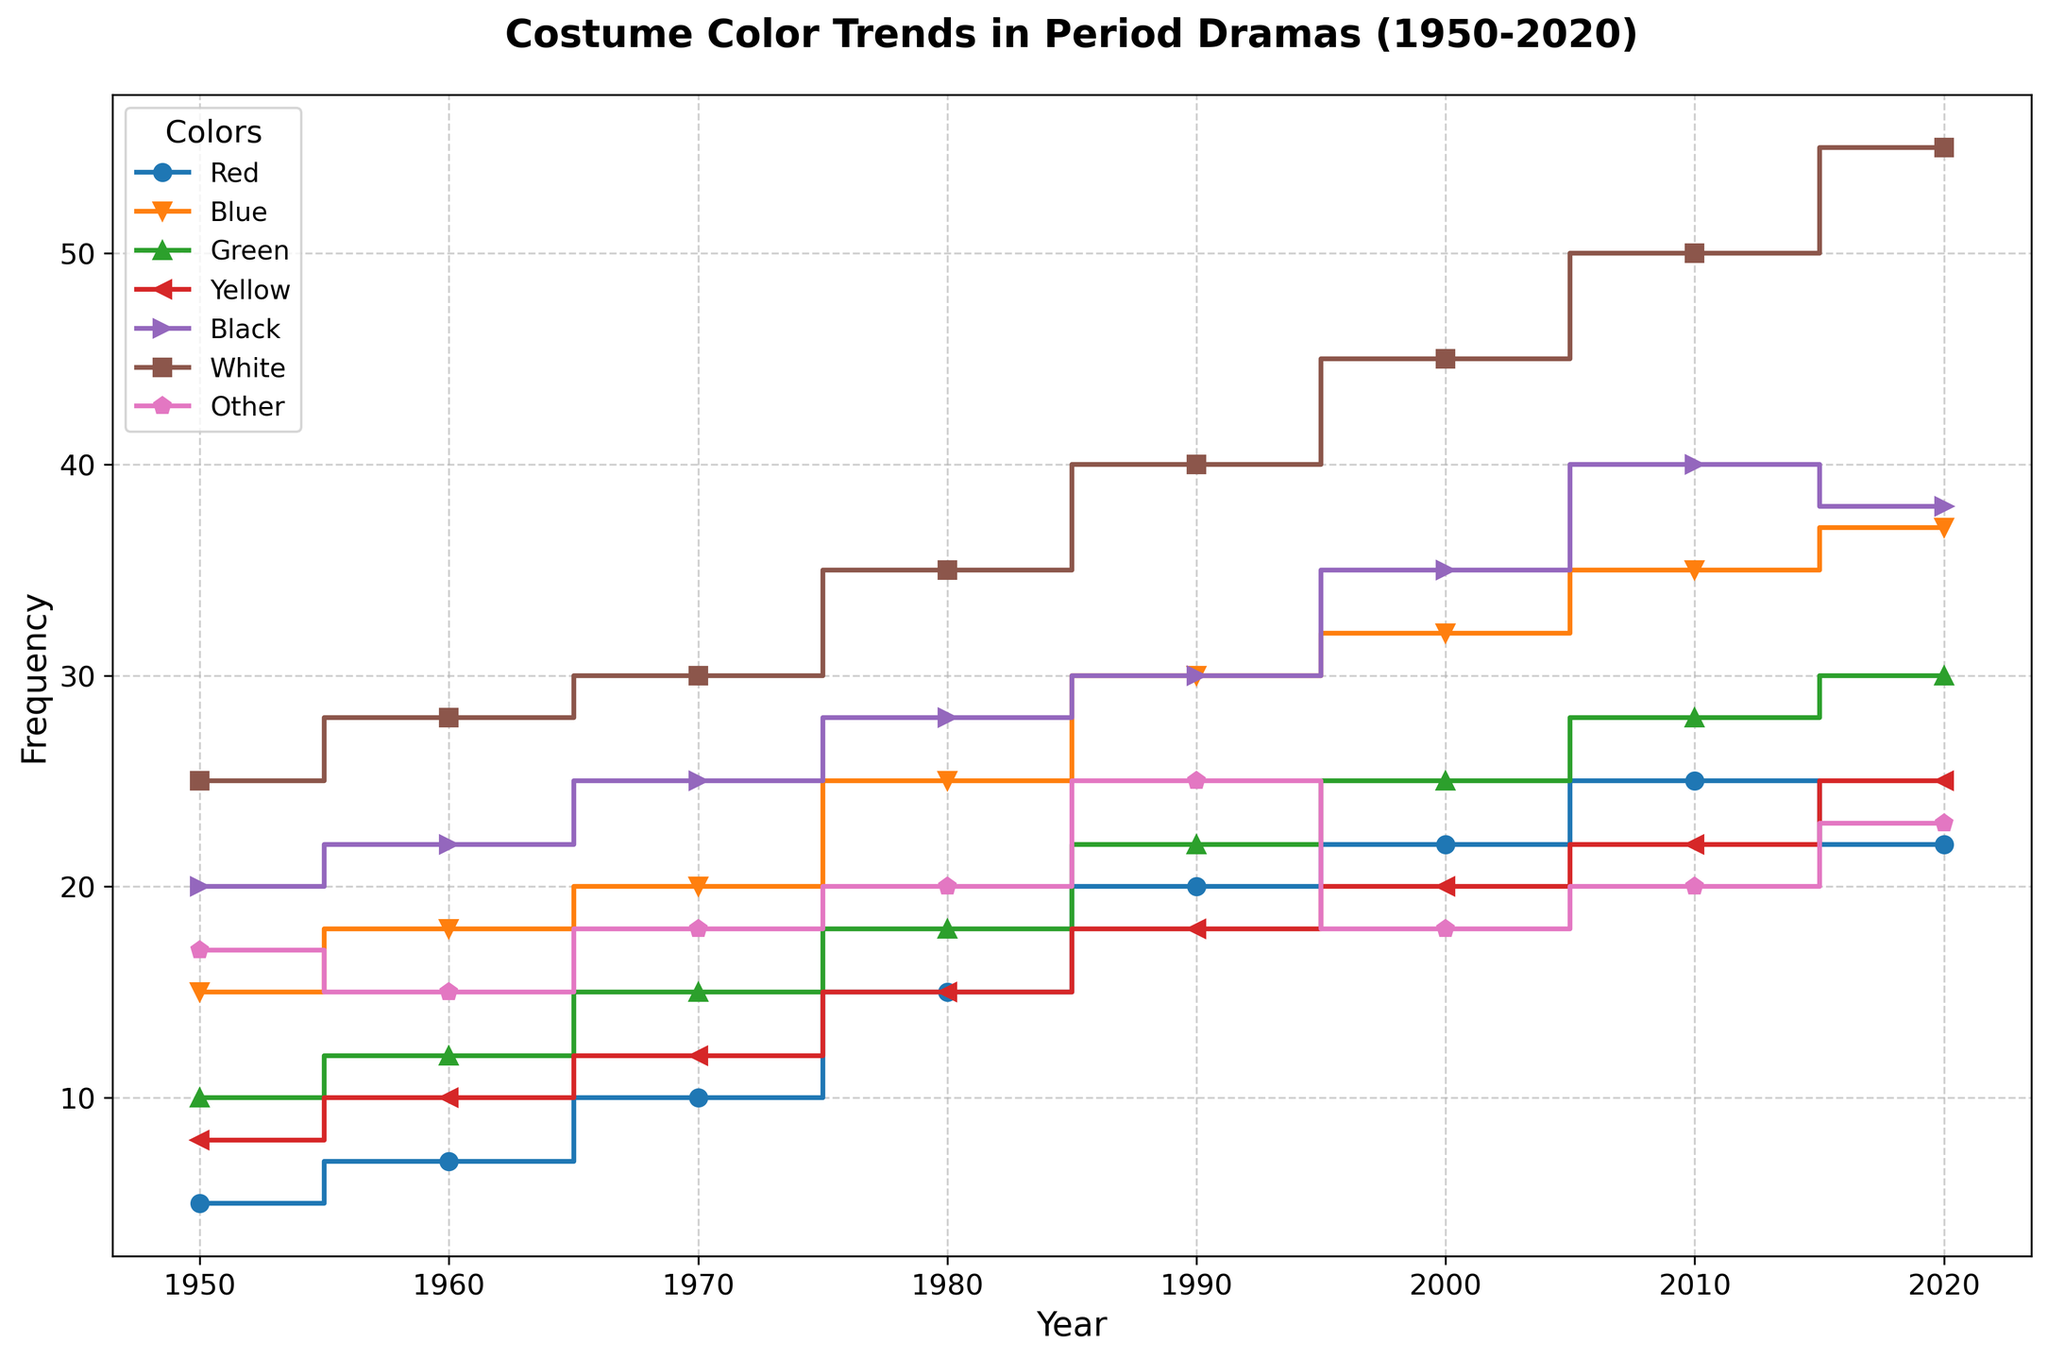What's the trend of the color 'Red' from 1950 to 2020? To deduce the trend, one should look at how the values for 'Red' change over the years in the plot. Starting from 1950, the values are 5, 7, 10, 15, 20, 22, 25, 22 respectively. The overall trend shows an increase from 1950 to 2010, with a slight drop in 2020.
Answer: Increasing with a slight drop in 2020 Which color had the highest frequency in 2020? Examining the highest points on the y-axis for the year 2020, the colors are listed with their respective values. 'White' has a value of 55, which is the highest among all colors in 2020.
Answer: White Compare the frequency of 'Black' and 'Blue' in 1980. Which one is higher? Check the values for 'Black' and 'Blue' in 1980. 'Black' has a value of 28 and 'Blue' is 25. Therefore, 'Black' is higher than 'Blue' in 1980.
Answer: Black What is the average frequency of 'Yellow' from 1950 to 2020? Sum the frequency values of 'Yellow' over all the given years (8, 10, 12, 15, 18, 20, 22, 25) and divide by the number of years (8). The total sum is 130, so the average is 130/8 = 16.25.
Answer: 16.25 In which year do 'Green' and 'Yellow' have equal frequencies? Look at each year and compare the values of 'Green' and 'Yellow'. In 2020, both 'Green' and 'Yellow' have a frequency of 25.
Answer: 2020 By how much did the frequency of 'White' increase from 1950 to 2020? The value for 'White' in 1950 is 25 and in 2020 is 55. The increase is calculated by subtracting the 1950 value from the 2020 value: 55 - 25 = 30.
Answer: 30 What is the total frequency of all colors combined in 1990? Add the frequency values of all colors in 1990: 20 (Red) + 30 (Blue) + 22 (Green) + 18 (Yellow) + 30 (Black) + 40 (White) + 25 (Other) = 185.
Answer: 185 Which color shows a decrease in frequency from 2010 to 2020? Compare the values from 2010 to 2020 for each color. 'Red' has a value of 25 in 2010 and 22 in 2020, showing a decrease. The same analysis for other colors shows no other decreases.
Answer: Red What is the median frequency of 'Other' across all years? List the frequencies for 'Other' in ascending order (15, 17, 18, 18, 20, 20, 23, 25), then find the middle value. Since there are 8 values, the median will be the average of the 4th and 5th values: (18+20)/2 = 19.
Answer: 19 